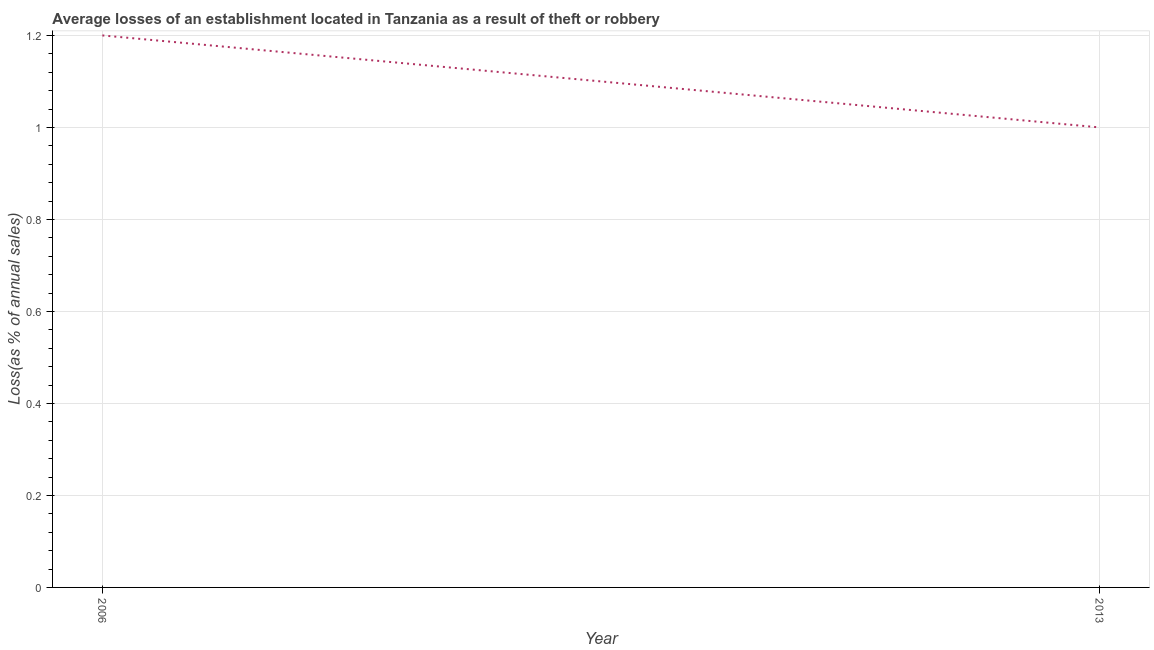Across all years, what is the minimum losses due to theft?
Make the answer very short. 1. In which year was the losses due to theft minimum?
Give a very brief answer. 2013. What is the difference between the losses due to theft in 2006 and 2013?
Offer a terse response. 0.2. What is the median losses due to theft?
Your answer should be compact. 1.1. In how many years, is the losses due to theft greater than 0.4 %?
Offer a very short reply. 2. Does the losses due to theft monotonically increase over the years?
Provide a short and direct response. No. How many lines are there?
Provide a short and direct response. 1. Are the values on the major ticks of Y-axis written in scientific E-notation?
Your response must be concise. No. Does the graph contain any zero values?
Provide a short and direct response. No. Does the graph contain grids?
Make the answer very short. Yes. What is the title of the graph?
Provide a short and direct response. Average losses of an establishment located in Tanzania as a result of theft or robbery. What is the label or title of the Y-axis?
Offer a very short reply. Loss(as % of annual sales). What is the Loss(as % of annual sales) of 2013?
Offer a very short reply. 1. 